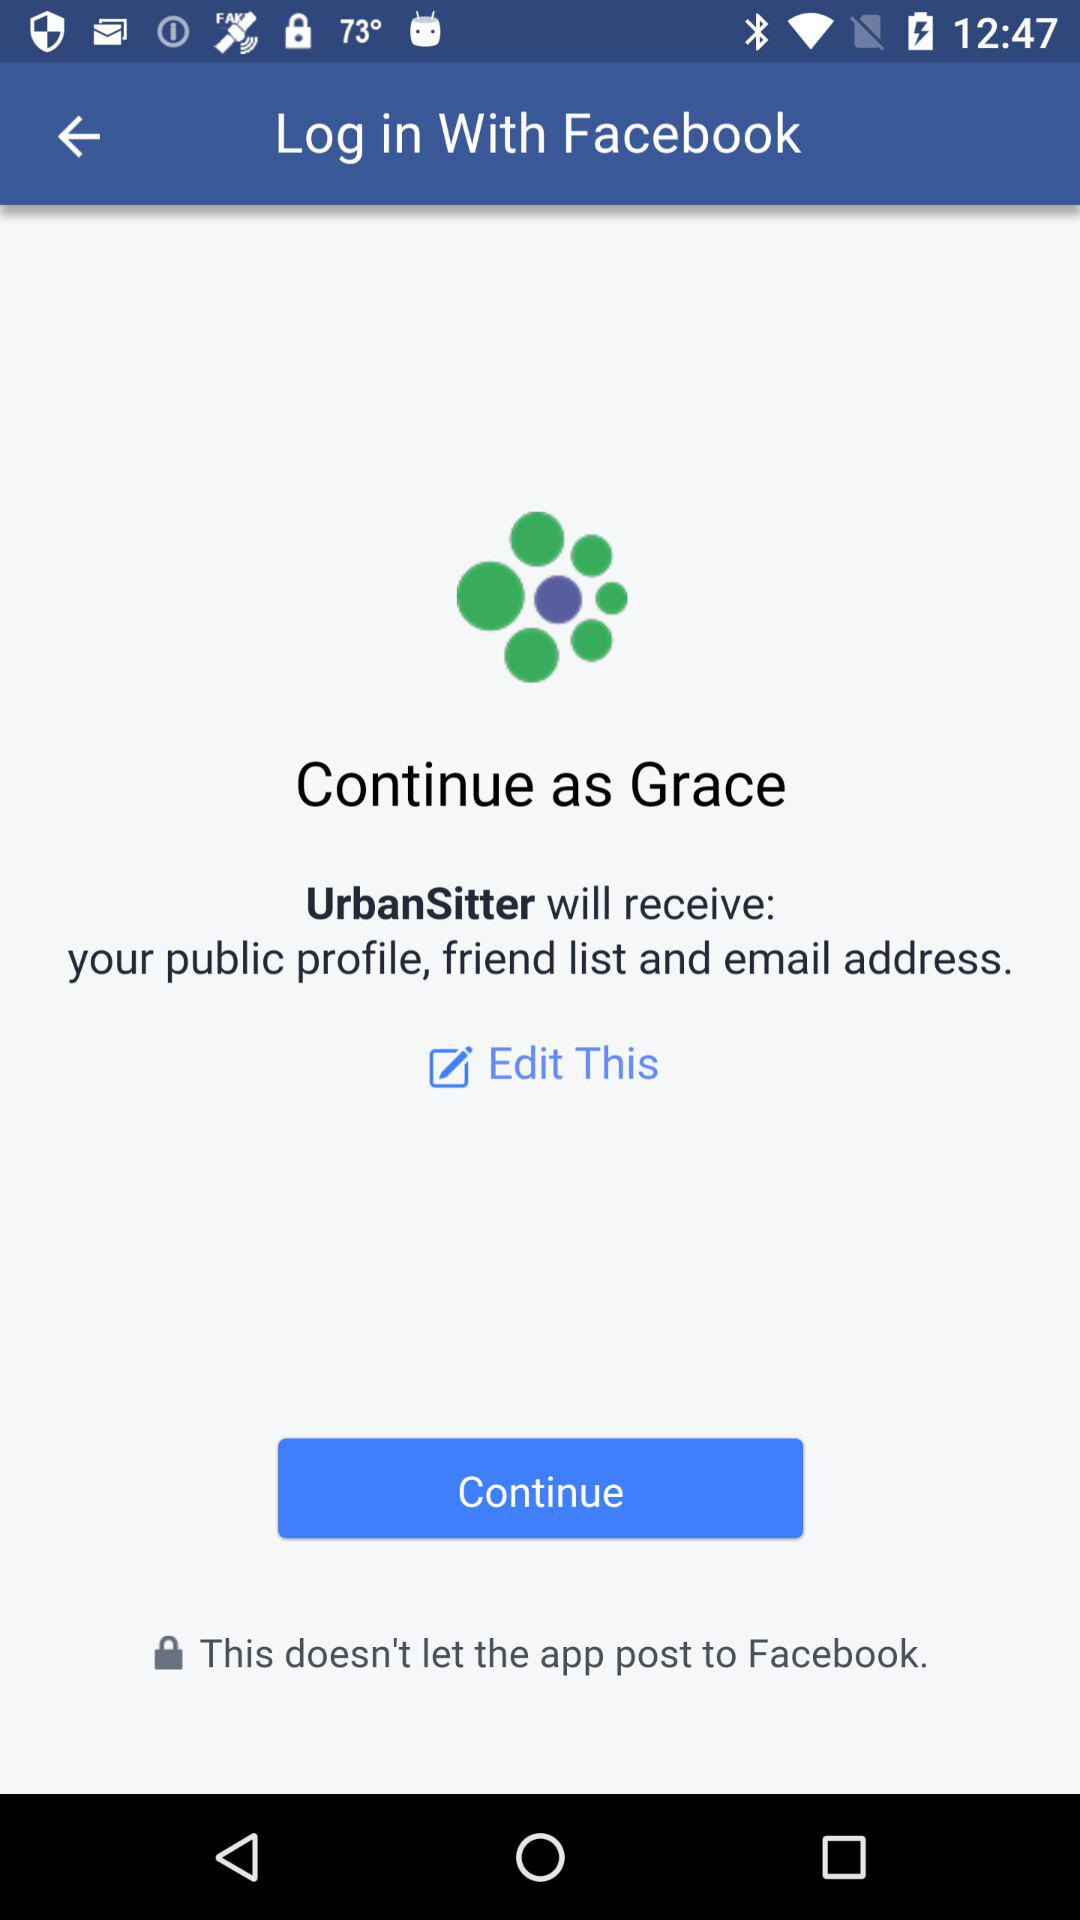What is the name of the user? The name of the user is Grace. 